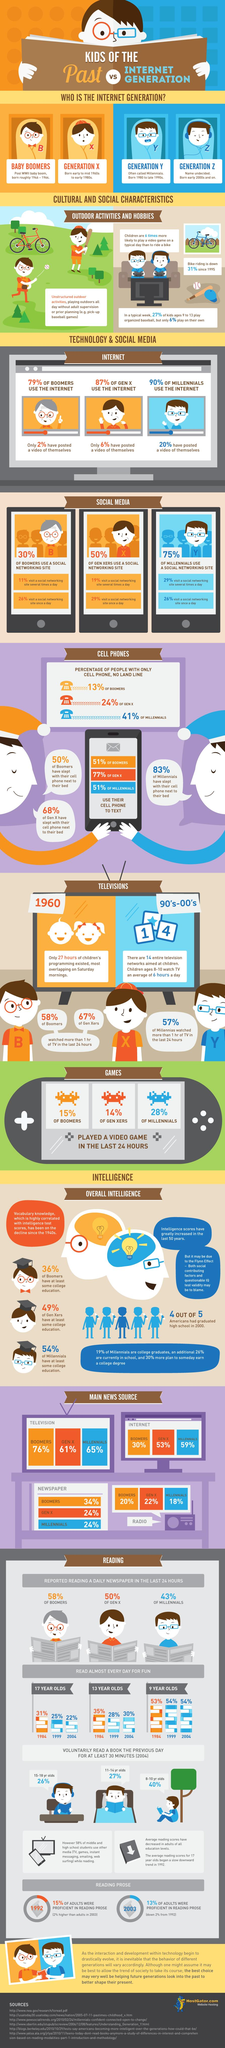Specify some key components in this picture. People born during the mid-1960s to the early 1980s are typically referred to as members of Generation X. According to a recent study, 51% of baby boomers use their cell phones to text. According to a survey, 58% of baby boomers reported reading a daily newspaper. According to a recent survey, 20% of millennials have posted a video of themselves on social media. According to a recent survey, 28% of millennials played a video game in the last 24 hours. 